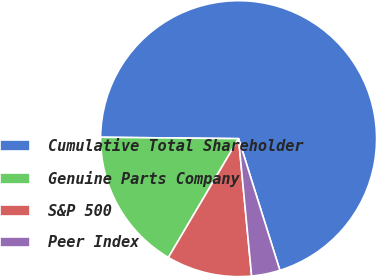Convert chart. <chart><loc_0><loc_0><loc_500><loc_500><pie_chart><fcel>Cumulative Total Shareholder<fcel>Genuine Parts Company<fcel>S&P 500<fcel>Peer Index<nl><fcel>70.01%<fcel>16.67%<fcel>10.0%<fcel>3.33%<nl></chart> 